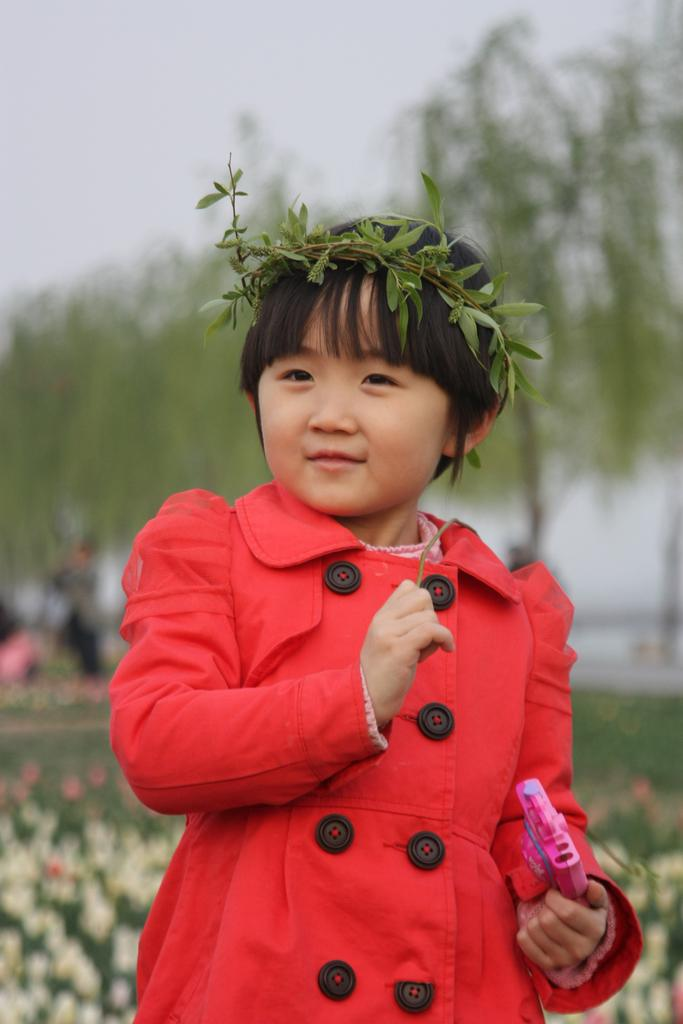Who is the main subject in the image? There is a girl in the image. What is the girl wearing? The girl is wearing a red dress and a crown. What is the girl holding in her hand? The girl is holding something in her hand, but we cannot determine what it is from the image. How would you describe the background of the image? The background of the image is blurred. What direction is the maid facing in the image? There is no maid present in the image, only a girl wearing a crown. How many rings is the girl wearing on her fingers in the image? The girl is not wearing any rings on her fingers in the image. 